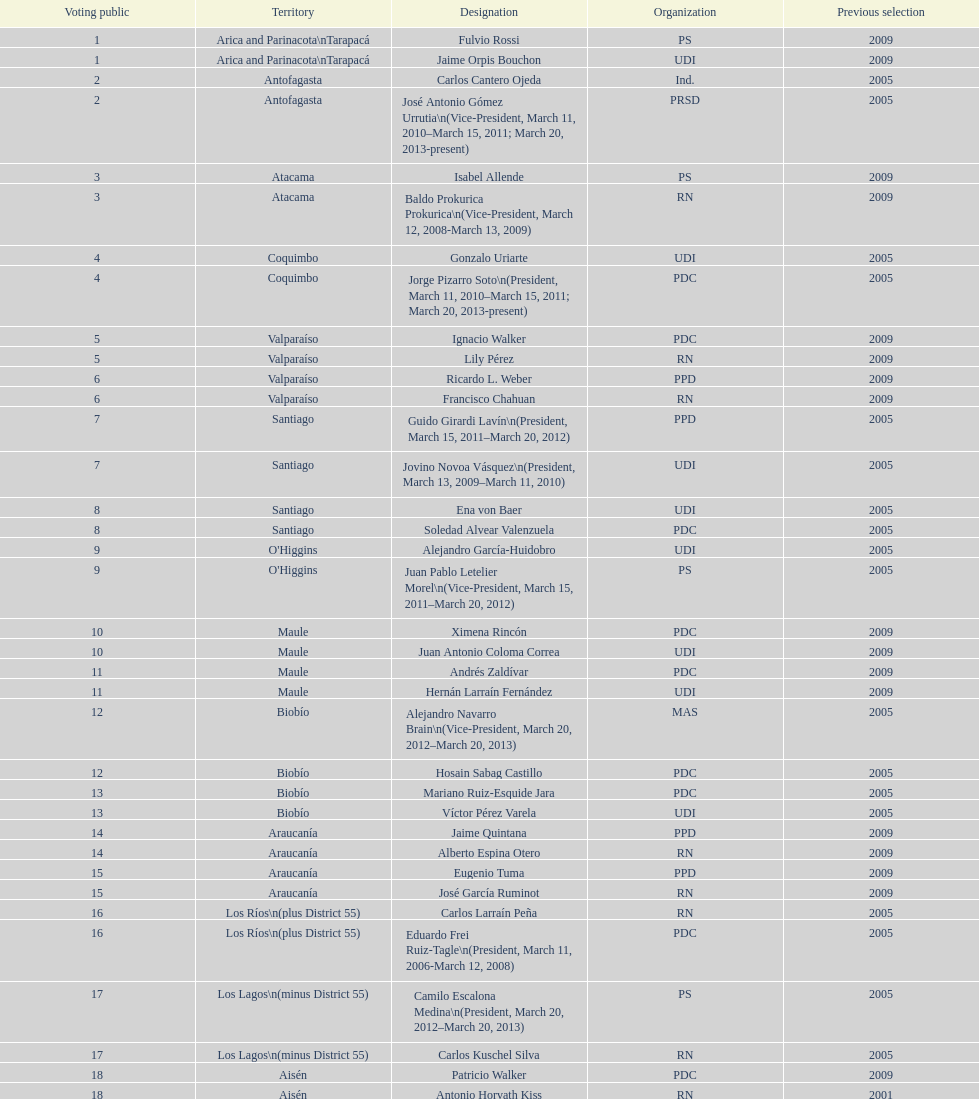What is the difference in years between constiuency 1 and 2? 4 years. 